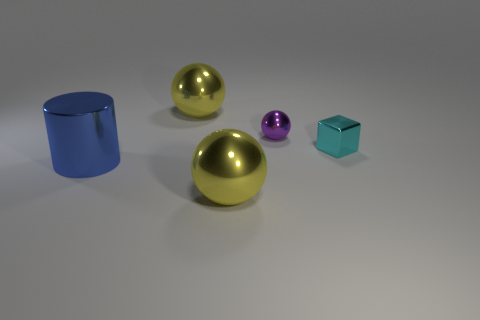Subtract all purple spheres. How many spheres are left? 2 Subtract all purple shiny spheres. How many spheres are left? 2 Add 5 big matte cylinders. How many objects exist? 10 Subtract 0 green balls. How many objects are left? 5 Subtract all balls. How many objects are left? 2 Subtract 2 spheres. How many spheres are left? 1 Subtract all purple balls. Subtract all gray blocks. How many balls are left? 2 Subtract all red cubes. How many green spheres are left? 0 Subtract all small cyan things. Subtract all small shiny blocks. How many objects are left? 3 Add 4 small cyan metal blocks. How many small cyan metal blocks are left? 5 